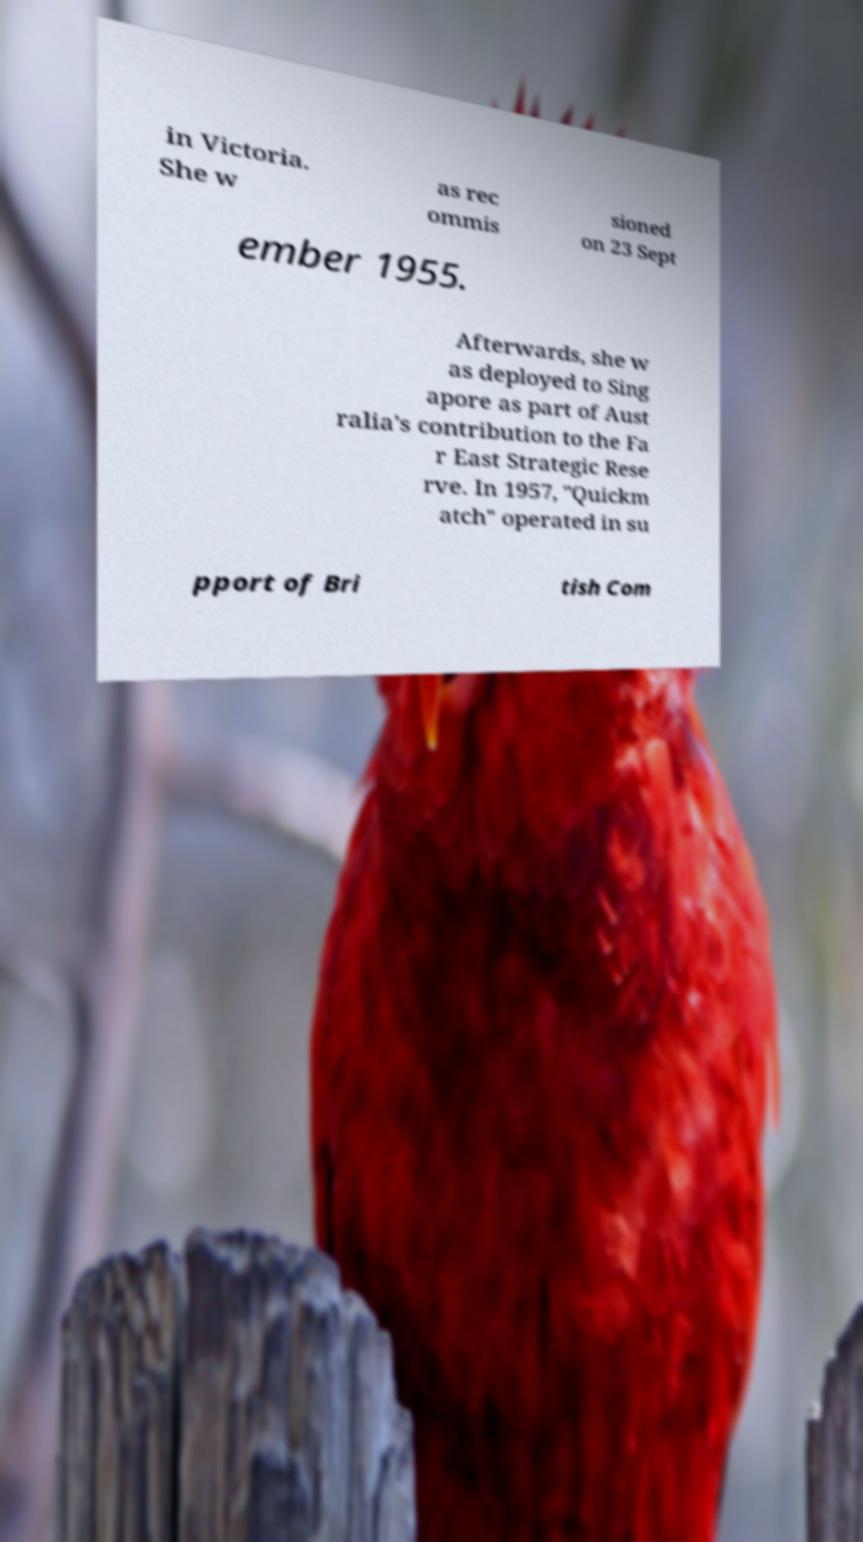For documentation purposes, I need the text within this image transcribed. Could you provide that? in Victoria. She w as rec ommis sioned on 23 Sept ember 1955. Afterwards, she w as deployed to Sing apore as part of Aust ralia's contribution to the Fa r East Strategic Rese rve. In 1957, "Quickm atch" operated in su pport of Bri tish Com 